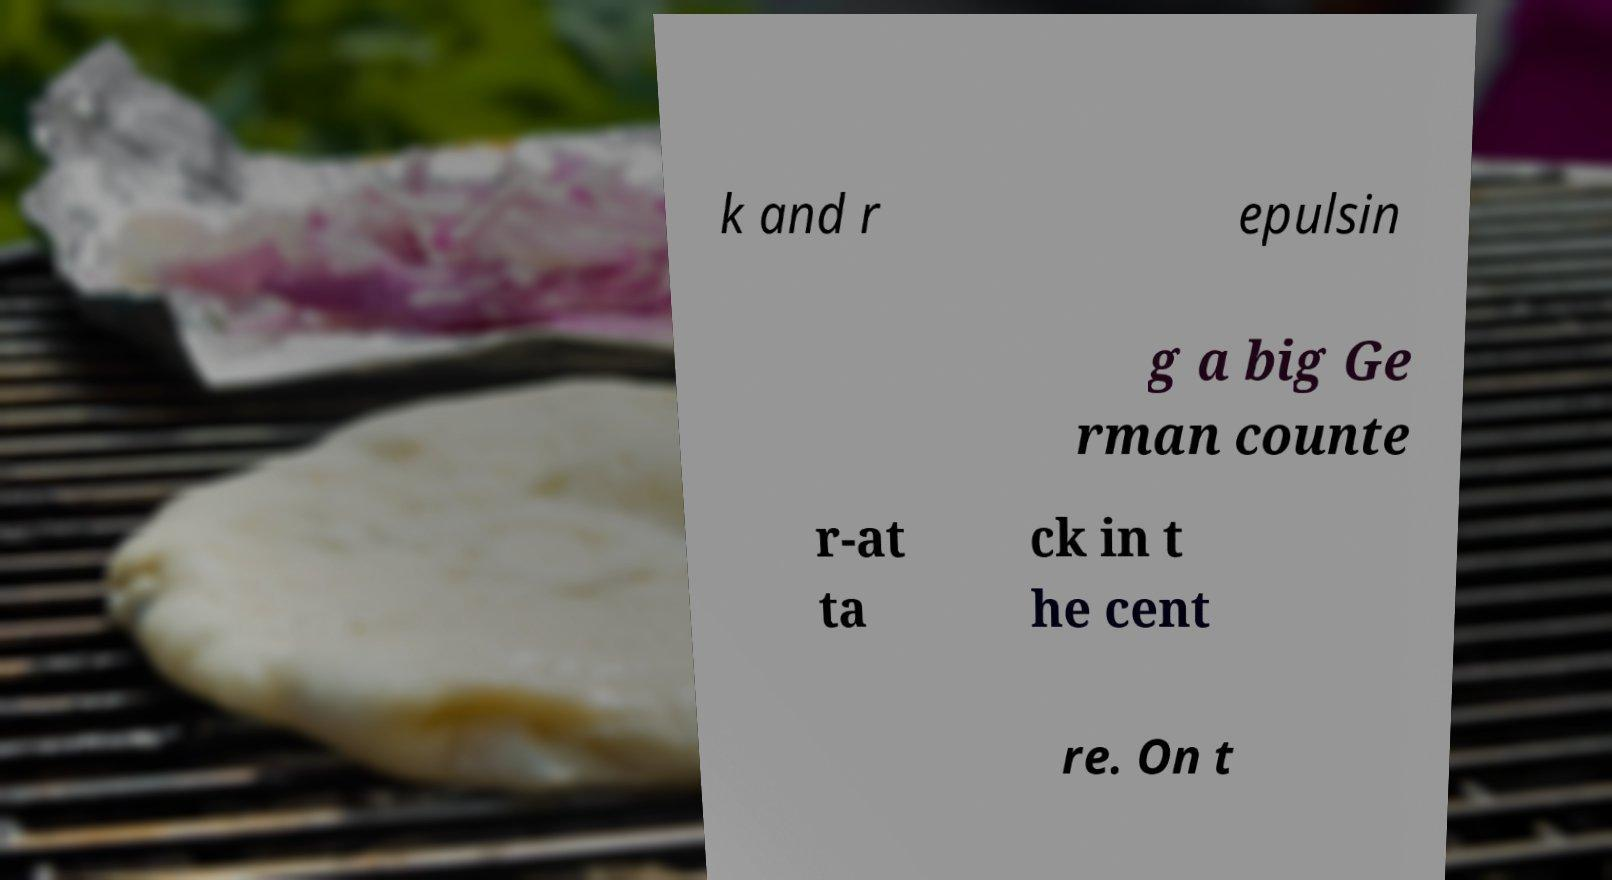Could you assist in decoding the text presented in this image and type it out clearly? k and r epulsin g a big Ge rman counte r-at ta ck in t he cent re. On t 